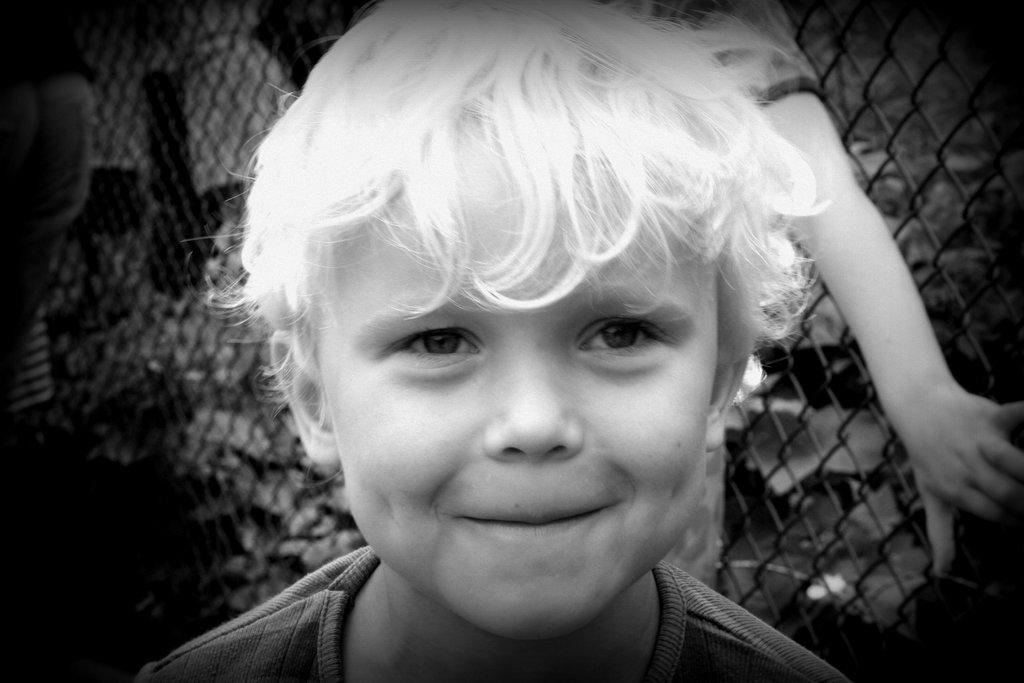What is the color scheme of the image? The image is black and white. Who is the main subject in the image? There is a boy in the image. What can be seen in the background of the image? The background of the image includes fencing. Are there any other people visible in the image? Yes, there is a person in the background of the image. What type of corn can be seen growing in the image? There is no corn present in the image; it is a black and white image featuring a boy and fencing in the background. 